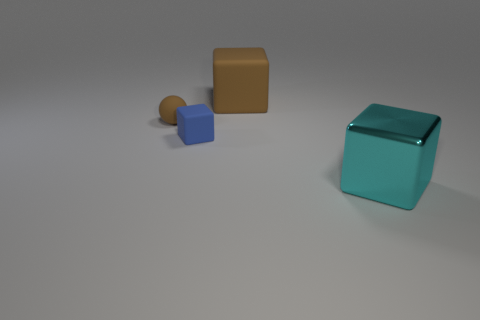Add 2 small spheres. How many objects exist? 6 Subtract all balls. How many objects are left? 3 Add 4 brown matte spheres. How many brown matte spheres exist? 5 Subtract 0 purple blocks. How many objects are left? 4 Subtract all tiny purple rubber objects. Subtract all tiny blue cubes. How many objects are left? 3 Add 4 tiny brown matte spheres. How many tiny brown matte spheres are left? 5 